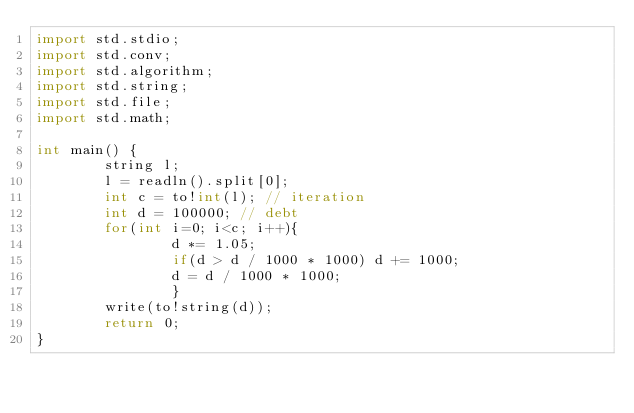<code> <loc_0><loc_0><loc_500><loc_500><_D_>import std.stdio;
import std.conv;
import std.algorithm;
import std.string;
import std.file;
import std.math;
 
int main() {
        string l;
        l = readln().split[0];
        int c = to!int(l); // iteration
        int d = 100000; // debt
        for(int i=0; i<c; i++){
                d *= 1.05;
                if(d > d / 1000 * 1000) d += 1000;
                d = d / 1000 * 1000;
                }
        write(to!string(d));
        return 0;
}</code> 